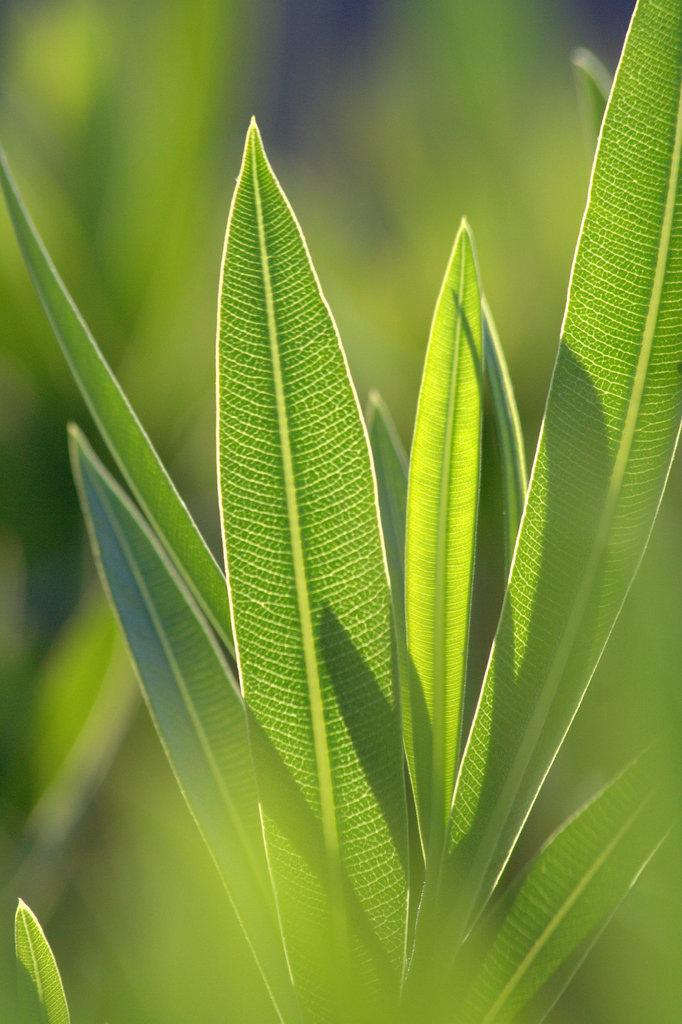What type of vegetation can be seen in the image? There are leaves visible in the image. Can you describe the background of the image? The background of the image is blurred. Is there a grandmother present in the image? There is no mention or indication of a grandmother in the image. Can you see any fights or attacks happening in the image? There is no mention or indication of any fights or attacks in the image. 